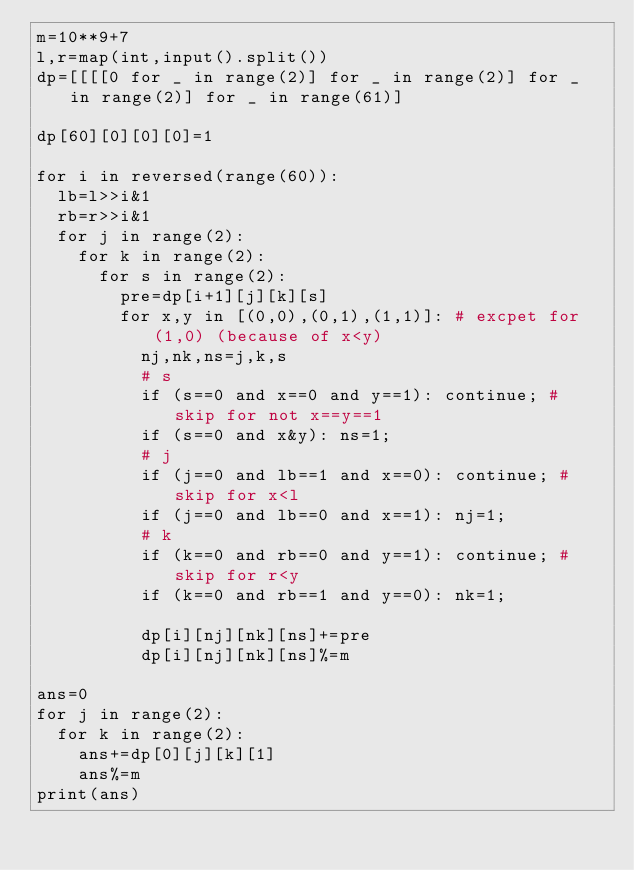Convert code to text. <code><loc_0><loc_0><loc_500><loc_500><_Python_>m=10**9+7
l,r=map(int,input().split())
dp=[[[[0 for _ in range(2)] for _ in range(2)] for _ in range(2)] for _ in range(61)]

dp[60][0][0][0]=1

for i in reversed(range(60)):
  lb=l>>i&1
  rb=r>>i&1
  for j in range(2):
    for k in range(2):
      for s in range(2):
        pre=dp[i+1][j][k][s]
        for x,y in [(0,0),(0,1),(1,1)]: # excpet for (1,0) (because of x<y)
          nj,nk,ns=j,k,s
          # s
          if (s==0 and x==0 and y==1): continue; # skip for not x==y==1
          if (s==0 and x&y): ns=1;
          # j
          if (j==0 and lb==1 and x==0): continue; # skip for x<l
          if (j==0 and lb==0 and x==1): nj=1;
          # k
          if (k==0 and rb==0 and y==1): continue; # skip for r<y
          if (k==0 and rb==1 and y==0): nk=1;           
            
          dp[i][nj][nk][ns]+=pre
          dp[i][nj][nk][ns]%=m    
                  
ans=0             
for j in range(2):
  for k in range(2):
    ans+=dp[0][j][k][1]
    ans%=m
print(ans)
                  
                  </code> 